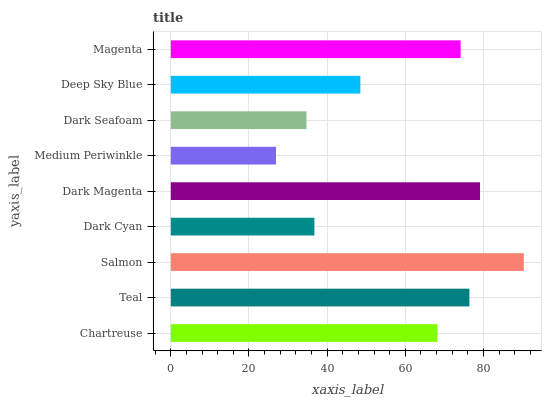Is Medium Periwinkle the minimum?
Answer yes or no. Yes. Is Salmon the maximum?
Answer yes or no. Yes. Is Teal the minimum?
Answer yes or no. No. Is Teal the maximum?
Answer yes or no. No. Is Teal greater than Chartreuse?
Answer yes or no. Yes. Is Chartreuse less than Teal?
Answer yes or no. Yes. Is Chartreuse greater than Teal?
Answer yes or no. No. Is Teal less than Chartreuse?
Answer yes or no. No. Is Chartreuse the high median?
Answer yes or no. Yes. Is Chartreuse the low median?
Answer yes or no. Yes. Is Dark Seafoam the high median?
Answer yes or no. No. Is Deep Sky Blue the low median?
Answer yes or no. No. 